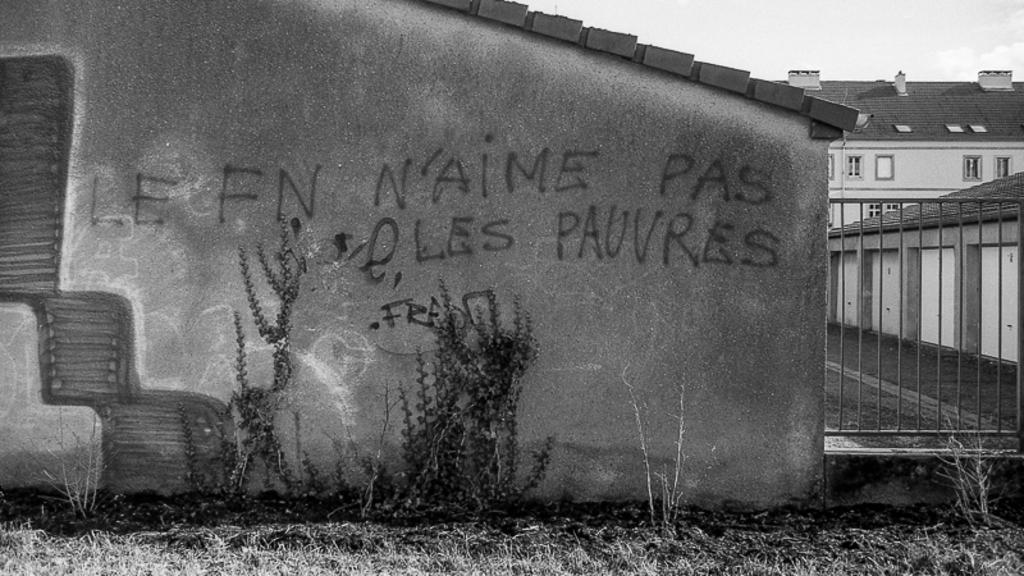Describe this image in one or two sentences. On the left side, there are texts and paintings on the wall of the building. Besides this building, there are plants and grass on the ground. On the right side, there is a fence. Outside this fence, there are buildings which are having roofs and windows. In the background, there are clouds in the sky. 